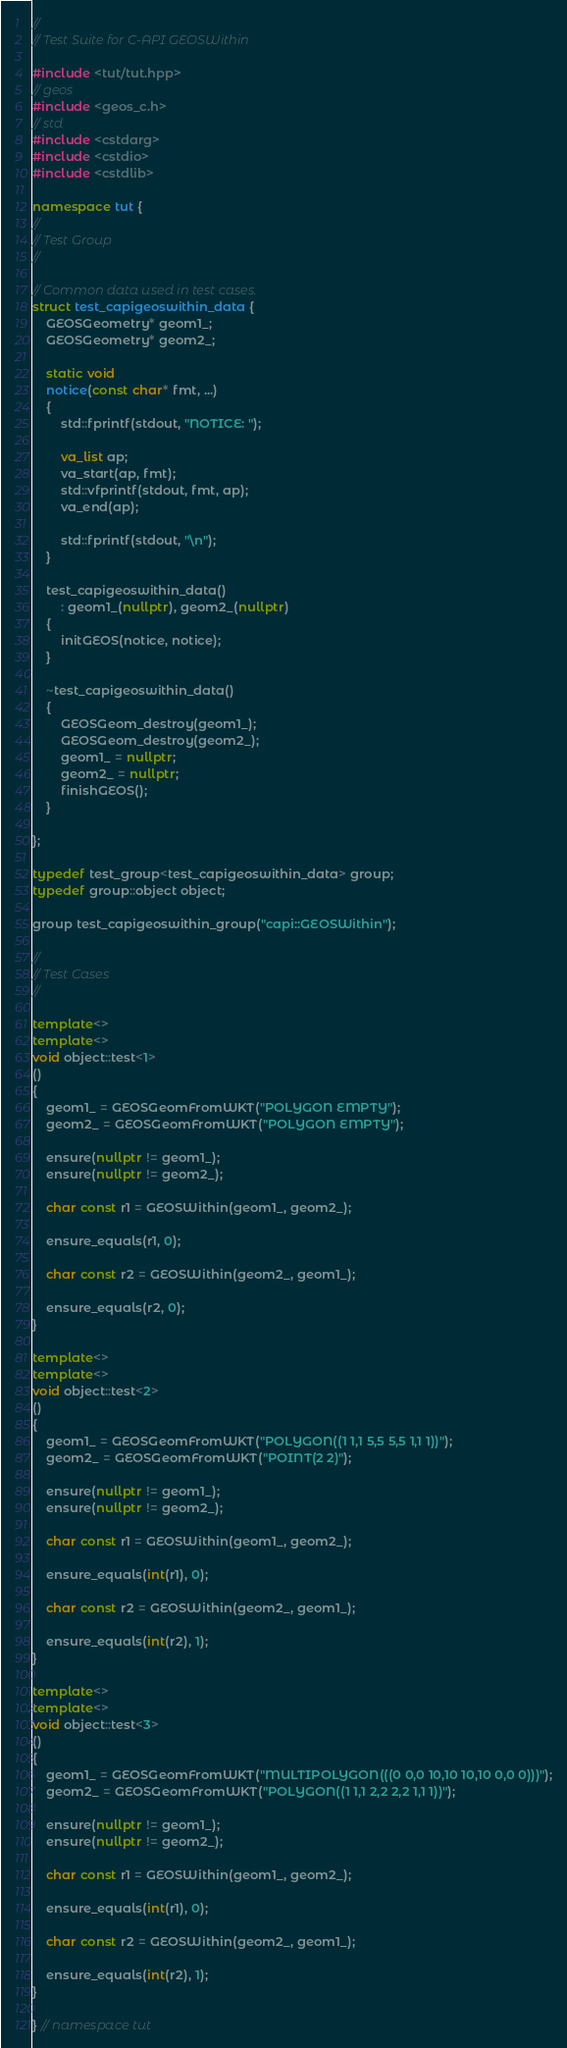<code> <loc_0><loc_0><loc_500><loc_500><_C++_>//
// Test Suite for C-API GEOSWithin

#include <tut/tut.hpp>
// geos
#include <geos_c.h>
// std
#include <cstdarg>
#include <cstdio>
#include <cstdlib>

namespace tut {
//
// Test Group
//

// Common data used in test cases.
struct test_capigeoswithin_data {
    GEOSGeometry* geom1_;
    GEOSGeometry* geom2_;

    static void
    notice(const char* fmt, ...)
    {
        std::fprintf(stdout, "NOTICE: ");

        va_list ap;
        va_start(ap, fmt);
        std::vfprintf(stdout, fmt, ap);
        va_end(ap);

        std::fprintf(stdout, "\n");
    }

    test_capigeoswithin_data()
        : geom1_(nullptr), geom2_(nullptr)
    {
        initGEOS(notice, notice);
    }

    ~test_capigeoswithin_data()
    {
        GEOSGeom_destroy(geom1_);
        GEOSGeom_destroy(geom2_);
        geom1_ = nullptr;
        geom2_ = nullptr;
        finishGEOS();
    }

};

typedef test_group<test_capigeoswithin_data> group;
typedef group::object object;

group test_capigeoswithin_group("capi::GEOSWithin");

//
// Test Cases
//

template<>
template<>
void object::test<1>
()
{
    geom1_ = GEOSGeomFromWKT("POLYGON EMPTY");
    geom2_ = GEOSGeomFromWKT("POLYGON EMPTY");

    ensure(nullptr != geom1_);
    ensure(nullptr != geom2_);

    char const r1 = GEOSWithin(geom1_, geom2_);

    ensure_equals(r1, 0);

    char const r2 = GEOSWithin(geom2_, geom1_);

    ensure_equals(r2, 0);
}

template<>
template<>
void object::test<2>
()
{
    geom1_ = GEOSGeomFromWKT("POLYGON((1 1,1 5,5 5,5 1,1 1))");
    geom2_ = GEOSGeomFromWKT("POINT(2 2)");

    ensure(nullptr != geom1_);
    ensure(nullptr != geom2_);

    char const r1 = GEOSWithin(geom1_, geom2_);

    ensure_equals(int(r1), 0);

    char const r2 = GEOSWithin(geom2_, geom1_);

    ensure_equals(int(r2), 1);
}

template<>
template<>
void object::test<3>
()
{
    geom1_ = GEOSGeomFromWKT("MULTIPOLYGON(((0 0,0 10,10 10,10 0,0 0)))");
    geom2_ = GEOSGeomFromWKT("POLYGON((1 1,1 2,2 2,2 1,1 1))");

    ensure(nullptr != geom1_);
    ensure(nullptr != geom2_);

    char const r1 = GEOSWithin(geom1_, geom2_);

    ensure_equals(int(r1), 0);

    char const r2 = GEOSWithin(geom2_, geom1_);

    ensure_equals(int(r2), 1);
}

} // namespace tut

</code> 